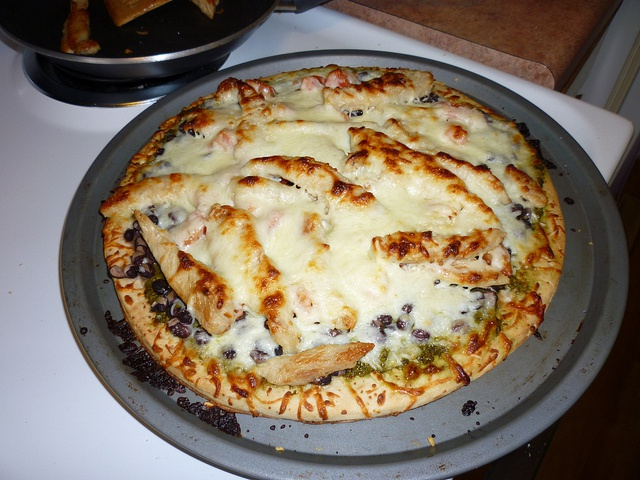Describe the objects in this image and their specific colors. I can see pizza in black, tan, olive, and beige tones and bowl in black, maroon, and gray tones in this image. 